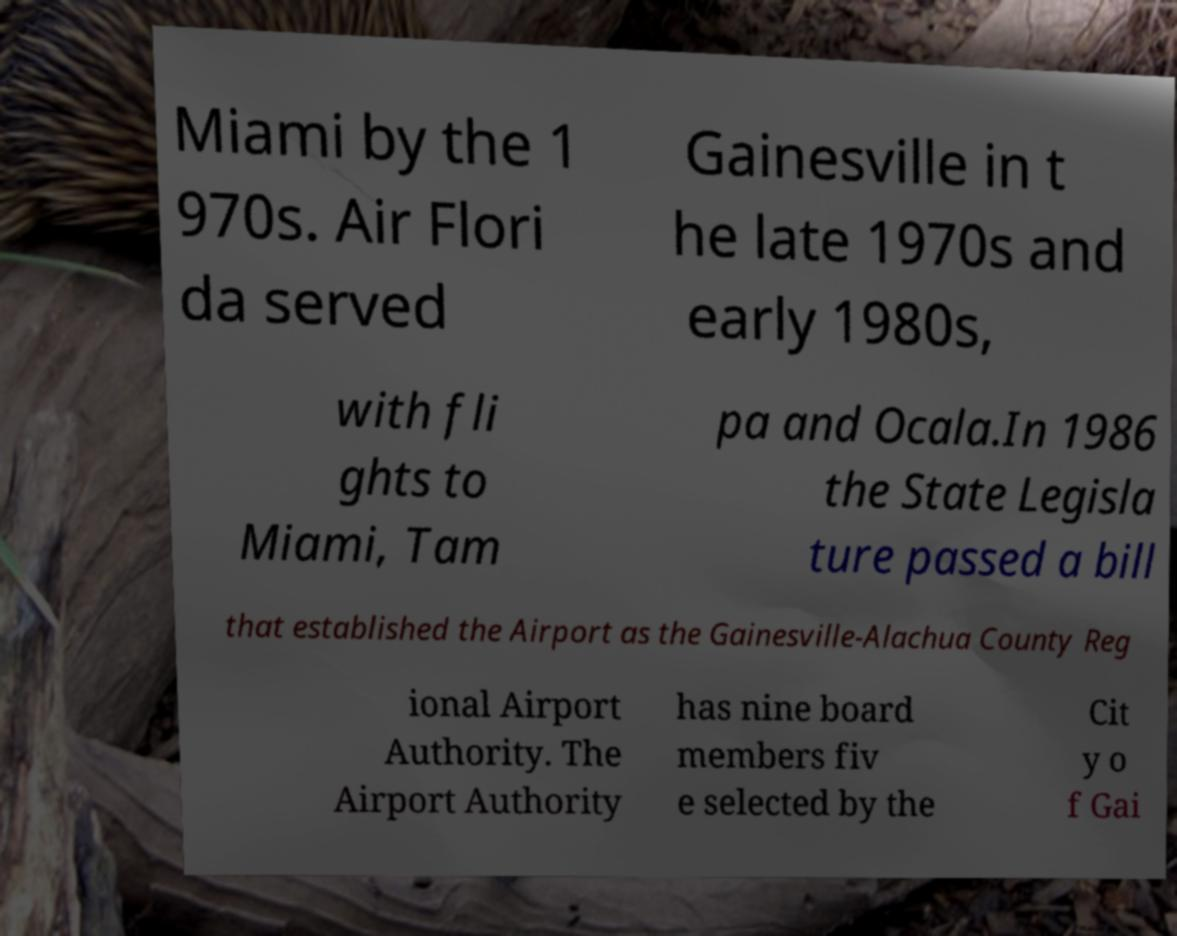Could you assist in decoding the text presented in this image and type it out clearly? Miami by the 1 970s. Air Flori da served Gainesville in t he late 1970s and early 1980s, with fli ghts to Miami, Tam pa and Ocala.In 1986 the State Legisla ture passed a bill that established the Airport as the Gainesville-Alachua County Reg ional Airport Authority. The Airport Authority has nine board members fiv e selected by the Cit y o f Gai 